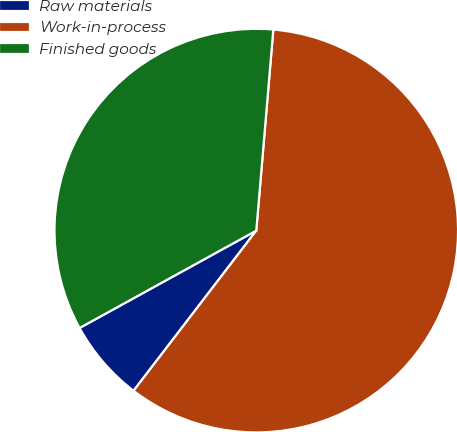Convert chart to OTSL. <chart><loc_0><loc_0><loc_500><loc_500><pie_chart><fcel>Raw materials<fcel>Work-in-process<fcel>Finished goods<nl><fcel>6.58%<fcel>59.06%<fcel>34.36%<nl></chart> 